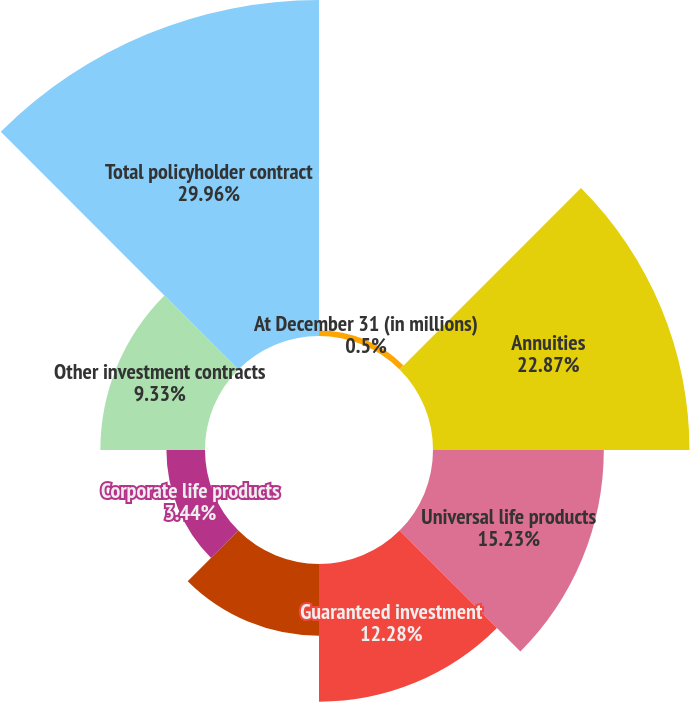Convert chart. <chart><loc_0><loc_0><loc_500><loc_500><pie_chart><fcel>At December 31 (in millions)<fcel>Annuities<fcel>Universal life products<fcel>Guaranteed investment<fcel>Variable products<fcel>Corporate life products<fcel>Other investment contracts<fcel>Total policyholder contract<nl><fcel>0.5%<fcel>22.87%<fcel>15.23%<fcel>12.28%<fcel>6.39%<fcel>3.44%<fcel>9.33%<fcel>29.96%<nl></chart> 